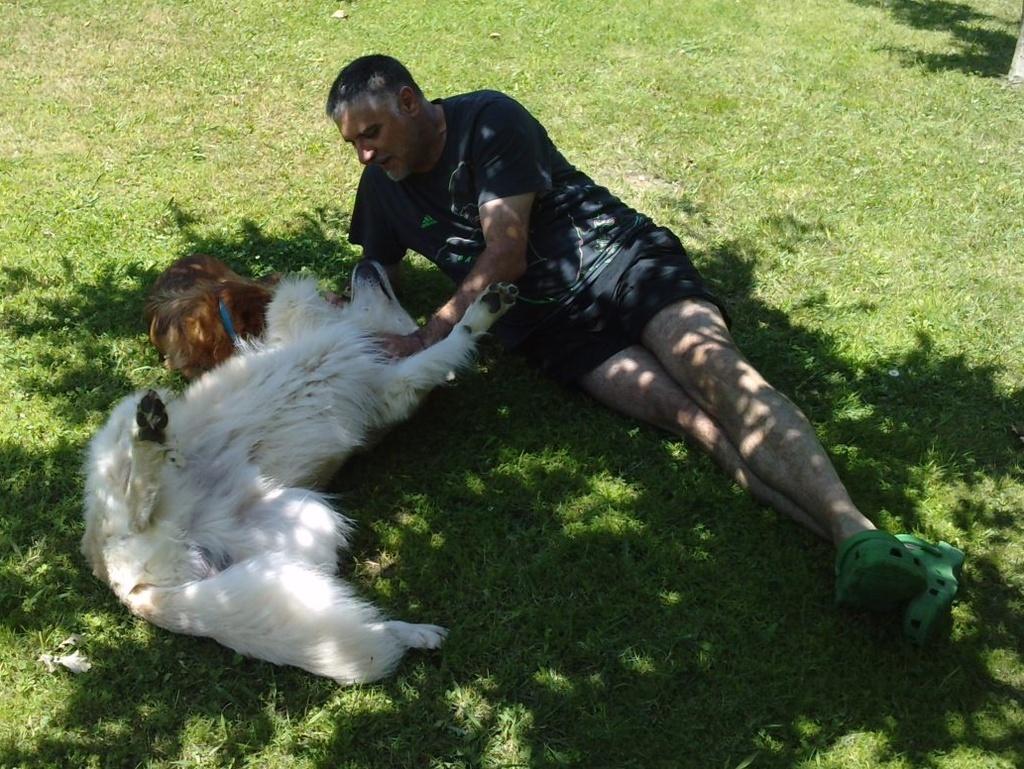Please provide a concise description of this image. In this image i can see a man laying and a dog laying on the floor. 